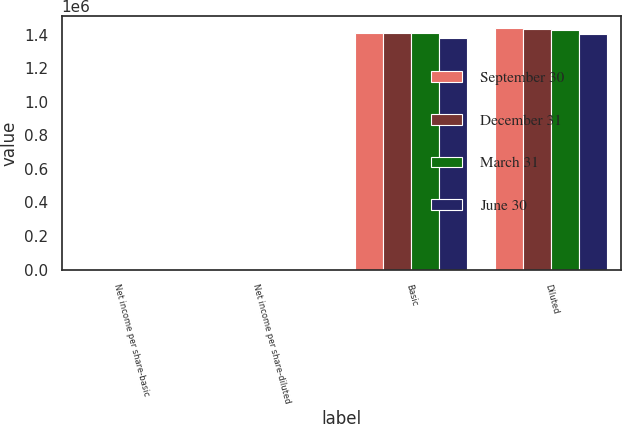<chart> <loc_0><loc_0><loc_500><loc_500><stacked_bar_chart><ecel><fcel>Net income per share-basic<fcel>Net income per share-diluted<fcel>Basic<fcel>Diluted<nl><fcel>September 30<fcel>0.18<fcel>0.17<fcel>1.40631e+06<fcel>1.43758e+06<nl><fcel>December 31<fcel>0.18<fcel>0.17<fcel>1.41192e+06<fcel>1.43576e+06<nl><fcel>March 31<fcel>0.2<fcel>0.2<fcel>1.40638e+06<fcel>1.42611e+06<nl><fcel>June 30<fcel>0.25<fcel>0.25<fcel>1.38058e+06<fcel>1.40275e+06<nl></chart> 